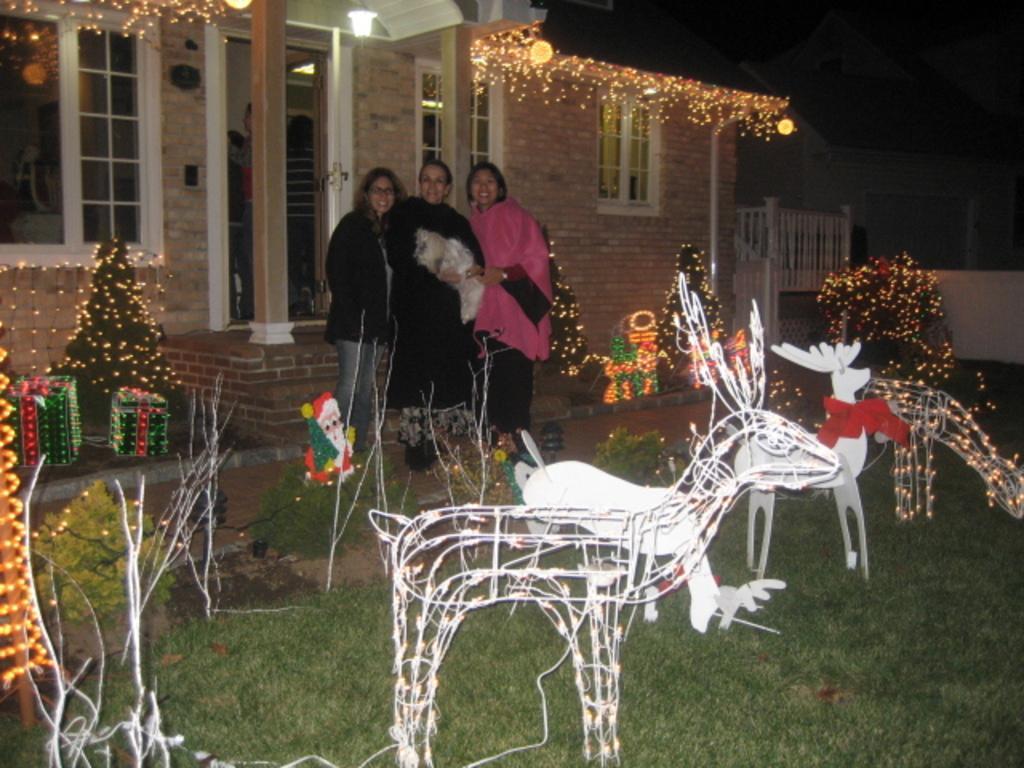In one or two sentences, can you explain what this image depicts? In this image I see 3 women over here who are smiling and I see decoration and I see the grass over here and I see the house and it is dark in the background and I see the lights. 